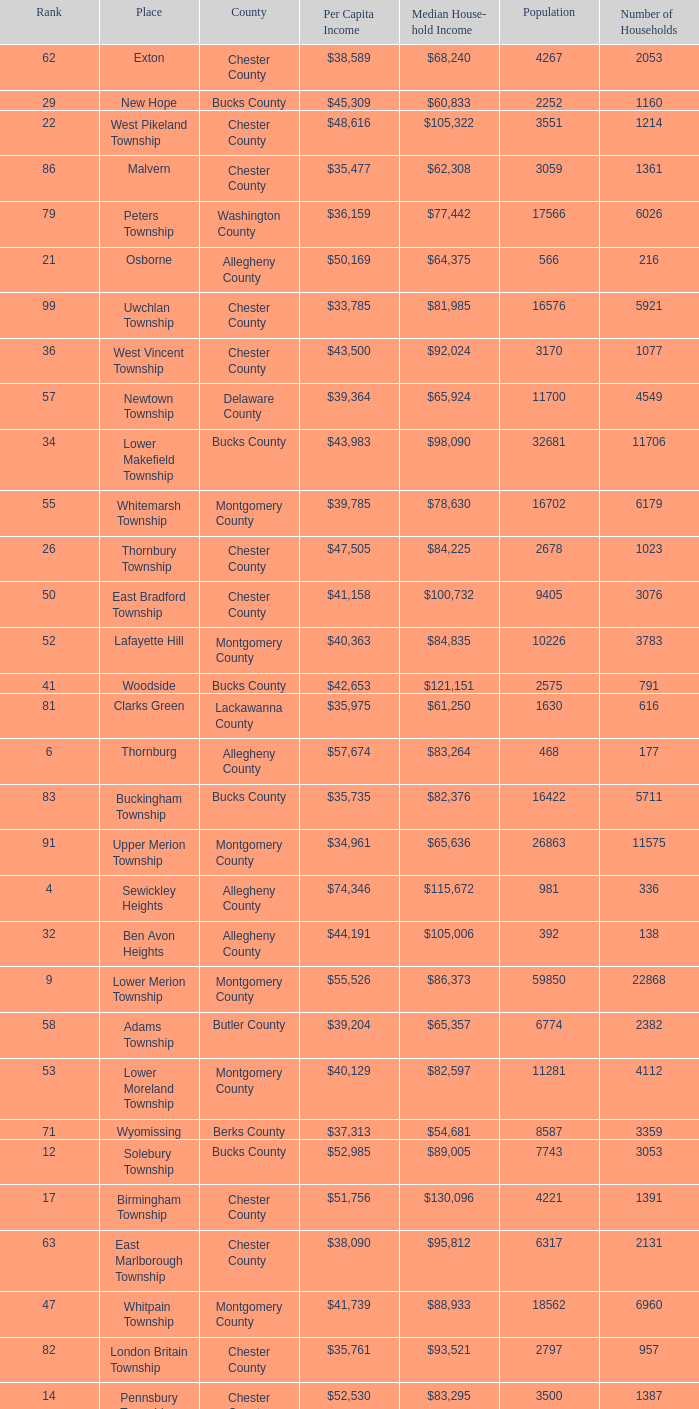What is the median household income for Woodside? $121,151. Help me parse the entirety of this table. {'header': ['Rank', 'Place', 'County', 'Per Capita Income', 'Median House- hold Income', 'Population', 'Number of Households'], 'rows': [['62', 'Exton', 'Chester County', '$38,589', '$68,240', '4267', '2053'], ['29', 'New Hope', 'Bucks County', '$45,309', '$60,833', '2252', '1160'], ['22', 'West Pikeland Township', 'Chester County', '$48,616', '$105,322', '3551', '1214'], ['86', 'Malvern', 'Chester County', '$35,477', '$62,308', '3059', '1361'], ['79', 'Peters Township', 'Washington County', '$36,159', '$77,442', '17566', '6026'], ['21', 'Osborne', 'Allegheny County', '$50,169', '$64,375', '566', '216'], ['99', 'Uwchlan Township', 'Chester County', '$33,785', '$81,985', '16576', '5921'], ['36', 'West Vincent Township', 'Chester County', '$43,500', '$92,024', '3170', '1077'], ['57', 'Newtown Township', 'Delaware County', '$39,364', '$65,924', '11700', '4549'], ['34', 'Lower Makefield Township', 'Bucks County', '$43,983', '$98,090', '32681', '11706'], ['55', 'Whitemarsh Township', 'Montgomery County', '$39,785', '$78,630', '16702', '6179'], ['26', 'Thornbury Township', 'Chester County', '$47,505', '$84,225', '2678', '1023'], ['50', 'East Bradford Township', 'Chester County', '$41,158', '$100,732', '9405', '3076'], ['52', 'Lafayette Hill', 'Montgomery County', '$40,363', '$84,835', '10226', '3783'], ['41', 'Woodside', 'Bucks County', '$42,653', '$121,151', '2575', '791'], ['81', 'Clarks Green', 'Lackawanna County', '$35,975', '$61,250', '1630', '616'], ['6', 'Thornburg', 'Allegheny County', '$57,674', '$83,264', '468', '177'], ['83', 'Buckingham Township', 'Bucks County', '$35,735', '$82,376', '16422', '5711'], ['91', 'Upper Merion Township', 'Montgomery County', '$34,961', '$65,636', '26863', '11575'], ['4', 'Sewickley Heights', 'Allegheny County', '$74,346', '$115,672', '981', '336'], ['32', 'Ben Avon Heights', 'Allegheny County', '$44,191', '$105,006', '392', '138'], ['9', 'Lower Merion Township', 'Montgomery County', '$55,526', '$86,373', '59850', '22868'], ['58', 'Adams Township', 'Butler County', '$39,204', '$65,357', '6774', '2382'], ['53', 'Lower Moreland Township', 'Montgomery County', '$40,129', '$82,597', '11281', '4112'], ['71', 'Wyomissing', 'Berks County', '$37,313', '$54,681', '8587', '3359'], ['12', 'Solebury Township', 'Bucks County', '$52,985', '$89,005', '7743', '3053'], ['17', 'Birmingham Township', 'Chester County', '$51,756', '$130,096', '4221', '1391'], ['63', 'East Marlborough Township', 'Chester County', '$38,090', '$95,812', '6317', '2131'], ['47', 'Whitpain Township', 'Montgomery County', '$41,739', '$88,933', '18562', '6960'], ['82', 'London Britain Township', 'Chester County', '$35,761', '$93,521', '2797', '957'], ['14', 'Pennsbury Township', 'Chester County', '$52,530', '$83,295', '3500', '1387'], ['38', 'Schuylkill Township', 'Chester County', '$43,379', '$86,092', '6960', '2536'], ['18', 'Bradford Woods', 'Allegheny County', '$51,462', '$92,820', '1149', '464'], ['39', 'Fort Washington', 'Montgomery County', '$43,090', '$103,469', '3680', '1161'], ['51', 'Swarthmore', 'Delaware County', '$40,482', '$82,653', '6170', '1993'], ['75', 'Thompsonville', 'Washington County', '$36,853', '$75,000', '3592', '1228'], ['10', 'Rose Valley', 'Delaware County', '$54,202', '$114,373', '944', '347'], ['61', 'Sewickley Hills', 'Allegheny County', '$38,681', '$79,466', '652', '225'], ['16', 'Chesterbrook', 'Chester County', '$51,859', '$80,792', '4625', '2356'], ['56', 'Upper Providence Township', 'Delaware County', '$39,532', '$71,166', '10509', '4075'], ['89', 'West Whiteland Township', 'Chester County', '$35,031', '$71,545', '16499', '6618'], ['59', 'Edgewood', 'Allegheny County', '$39,188', '$52,153', '3311', '1639'], ['69', 'Chester Heights', 'Delaware County', '$37,707', '$70,236', '2481', '1056'], ['80', 'Ardmore', 'Montgomery County', '$36,111', '$60,966', '12616', '5529'], ['31', 'Abington Township', 'Lackawanna County', '$44,551', '$73,611', '1616', '609'], ['94', 'Tinicum Township', 'Bucks County', '$34,321', '$60,843', '4206', '1674'], ['95', 'Worcester Township', 'Montgomery County', '$34,264', '$77,200', '7789', '2896'], ['33', 'Bala-Cynwyd', 'Montgomery County', '$44,027', '$78,932', '9336', '3726'], ['5', 'Edgeworth', 'Allegheny County', '$69,350', '$99,144', '1730', '644'], ['3', 'Fox Chapel', 'Allegheny County', '$80,610', '$141,298', '5436', '1875'], ['11', 'Haysville', 'Allegheny County', '$53,151', '$33,750', '78', '36'], ['30', 'Willistown', 'Chester County', '$45,010', '$77,555', '10011', '3806'], ['35', 'Blue Bell', 'Montgomery County', '$43,813', '$94,160', '6395', '2434'], ['24', 'Spring House', 'Montgomery County', '$47,661', '$89,000', '3290', '1347'], ['27', 'Edgmont Township', 'Delaware County', '$46,848', '$88,303', '3918', '1447'], ['48', 'Bell Acres', 'Allegheny County', '$41,202', '$61,094', '1382', '520'], ['88', 'Narberth', 'Montgomery County', '$35,165', '$60,408', '4233', '1904'], ['7', 'Rosslyn Farms', 'Allegheny County', '$56,612', '$87,500', '464', '184'], ['78', 'Wyndmoor', 'Montgomery County', '$36,205', '$72,219', '5601', '2144'], ['73', 'Aleppo Township', 'Allegheny County', '$37,187', '$59,167', '1039', '483'], ['60', 'Dresher', 'Montgomery County', '$38,865', '$99,231', '5610', '1765'], ['42', 'Wrightstown Township', 'Bucks County', '$42,623', '$82,875', '2839', '971'], ['64', 'Doylestown Township', 'Bucks County', '$38,031', '$81,226', '17619', '5999'], ['49', 'Penn Wynne', 'Montgomery County', '$41,199', '$78,398', '5382', '2072'], ['44', 'Seven Springs', 'Fayette County', '$42,131', '$48,750', '127', '63'], ['74', 'Westtown Township', 'Chester County', '$36,894', '$85,049', '10352', '3705'], ['28', 'Kennett Township', 'Chester County', '$46,669', '$85,104', '6451', '2457'], ['43', 'Upper St.Clair Township', 'Allegheny County', '$42,413', '$87,581', '20053', '6966'], ['19', 'Easttown Township', 'Chester County', '$51,028', '$95,548', '10270', '3758'], ['87', 'Pine Township', 'Allegheny County', '$35,202', '$85,817', '7683', '2411'], ['77', 'Newlin Township', 'Chester County', '$36,804', '$68,828', '1150', '429'], ['8', 'Upper Makefield Township', 'Bucks County', '$56,288', '$102,759', '7180', '2512'], ['98', 'Concord Township', 'Delaware County', '$33,800', '$85,503', '9933', '3384'], ['20', 'Villanova', 'Montgomery County', '$50,204', '$159,538', '9060', '1902'], ['25', 'Tredyffrin Township', 'Chester County', '$47,584', '$82,258', '29062', '12223'], ['90', 'Timber Hills', 'Lebanon County', '$34,974', '$55,938', '329', '157'], ['45', 'Charlestown Township', 'Chester County', '$41,878', '$89,813', '4051', '1340'], ['54', 'Radnor Township', 'Delaware County', '$39,813', '$74,272', '30878', '10347'], ['72', 'Heath Township', 'Jefferson County', '$37,309', '$42,500', '160', '77'], ['15', 'Pocopson Township', 'Chester County', '$51,883', '$98,215', '3350', '859'], ['93', 'Newtown Township', 'Bucks County', '$34,335', '$80,532', '18206', '6761'], ['66', 'Churchill', 'Allegheny County', '$37,964', '$67,321', '3566', '1519'], ['1', 'Norwin', 'Westmoreland County', '$124,279', '$94,239', '18', '7'], ['13', 'Chadds Ford Township', 'Delaware County', '$52,974', '$84,100', '3170', '1314'], ['46', 'Lower Gwynedd Township', 'Montgomery County', '$41,868', '$74,351', '10422', '4177'], ['84', 'Devon-Berwyn', 'Chester County', '$35,551', '$74,886', '5067', '1978'], ['70', 'McMurray', 'Washington County', '$37,364', '$81,736', '4726', '1582'], ['92', 'Homewood', 'Beaver County', '$34,486', '$33,333', '147', '59'], ['97', 'Woodbourne', 'Bucks County', '$33,821', '$107,913', '3512', '1008'], ['37', 'Mount Gretna', 'Lebanon County', '$43,470', '$62,917', '242', '117'], ['76', 'Flying Hills', 'Berks County', '$36,822', '$59,596', '1191', '592'], ['96', 'Wyomissing Hills', 'Berks County', '$34,024', '$61,364', '2568', '986'], ['68', 'East Goshen Township', 'Chester County', '$37,775', '$64,777', '16824', '7165'], ['67', 'Franklin Park', 'Allegheny County', '$37,924', '$87,627', '11364', '3866'], ['23', 'Spring Ridge', 'Berks County', '$47,822', '$83,345', '786', '370'], ['65', 'Upper Dublin Township', 'Montgomery County', '$37,994', '$80,093', '25878', '9174'], ['2', 'Gladwyne', 'Montgomery County', '$90,940', '$159,905', '4050', '1476'], ['40', 'Marshall Township', 'Allegheny County', '$42,856', '$102,351', '5996', '1944'], ['85', 'North Abington Township', 'Lackawanna County', '$35,537', '$57,917', '782', '258']]} 